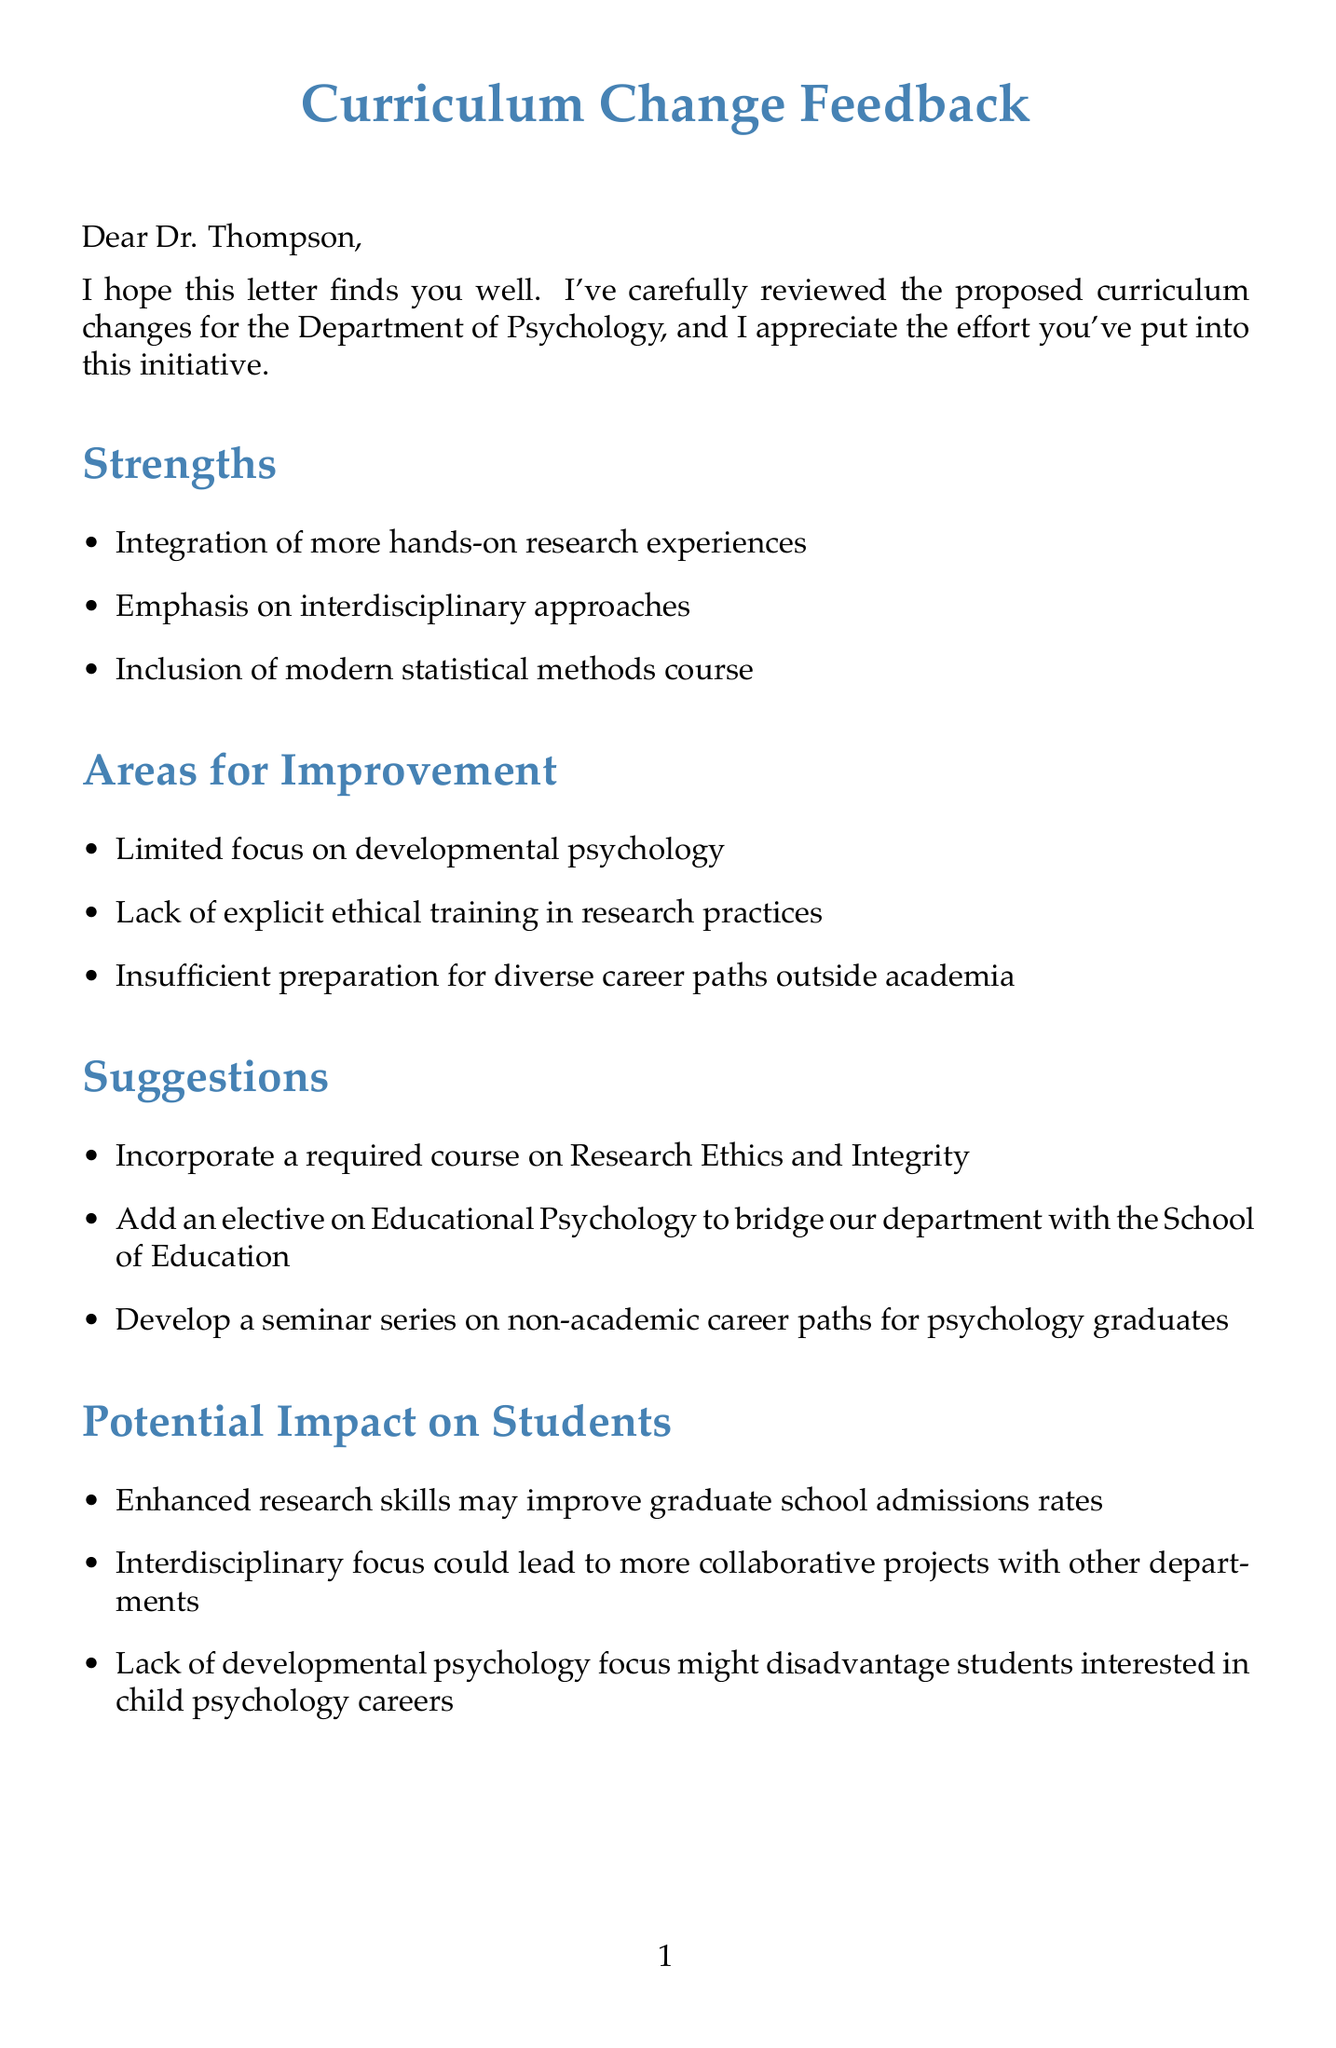What is the primary purpose of the letter? The primary purpose of the letter is to provide feedback regarding proposed curriculum changes for the Department of Psychology.
Answer: Feedback on curriculum changes Who is the letter addressed to? The letter is addressed to Dr. Thompson.
Answer: Dr. Thompson What are the strengths mentioned in the feedback? The strengths include integration of hands-on research experiences, interdisciplinary approaches, and modern statistical methods course.
Answer: Integration of more hands-on research experiences, Emphasis on interdisciplinary approaches, Inclusion of modern statistical methods course How many areas for improvement are identified? There are three areas for improvement identified in the body of the letter.
Answer: Three What suggestion is made regarding career paths? A suggestion is made to develop a seminar series on non-academic career paths for psychology graduates.
Answer: Develop a seminar series on non-academic career paths for psychology graduates What potential impact on students related to research skills is mentioned? The letter states that enhanced research skills may improve graduate school admissions rates.
Answer: Enhanced research skills may improve graduate school admissions rates Which faculty members are mentioned as involved? Faculty members mentioned include Dr. Sarah Johnson, Dr. Michael Lee, and Dr. Rachel Goldman.
Answer: Dr. Sarah Johnson, Dr. Michael Lee, Dr. Rachel Goldman What does the letter conclude with? The letter concludes with a statement about looking forward to discussing points in the next departmental meeting.
Answer: Discussing these points further in our next departmental meeting What is suggested to incorporate regarding ethics? It is suggested to incorporate a required course on Research Ethics and Integrity.
Answer: Incorporate a required course on Research Ethics and Integrity 